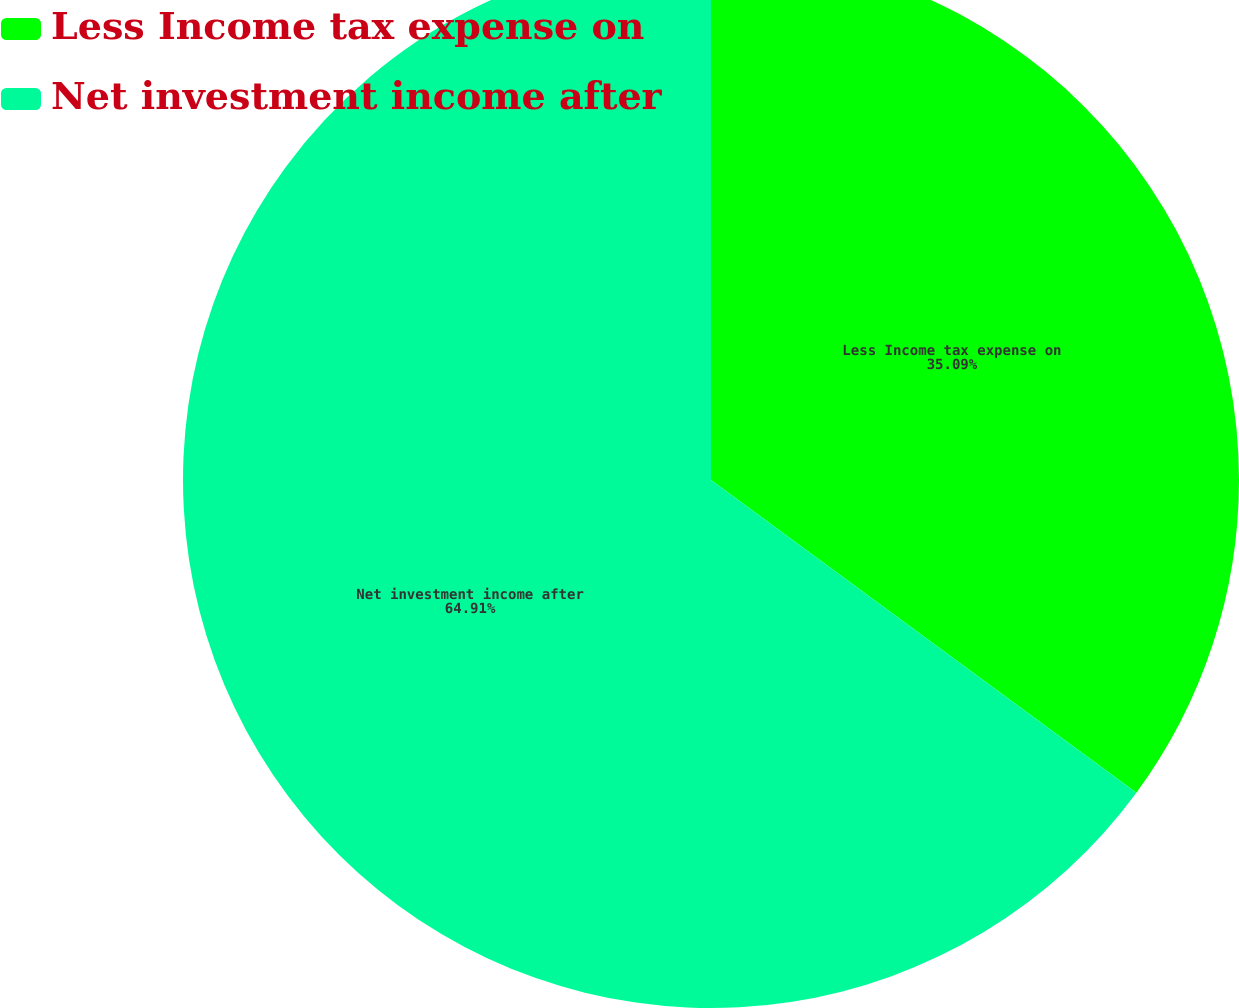<chart> <loc_0><loc_0><loc_500><loc_500><pie_chart><fcel>Less Income tax expense on<fcel>Net investment income after<nl><fcel>35.09%<fcel>64.91%<nl></chart> 